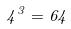Convert formula to latex. <formula><loc_0><loc_0><loc_500><loc_500>4 ^ { 3 } = 6 4</formula> 